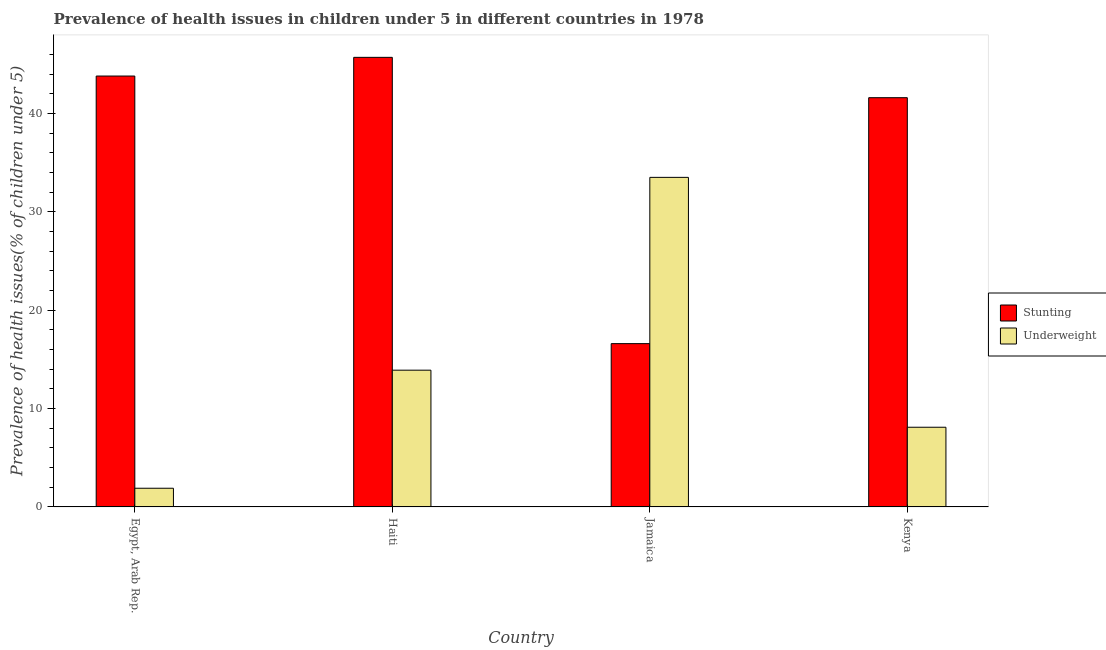Are the number of bars per tick equal to the number of legend labels?
Offer a terse response. Yes. How many bars are there on the 3rd tick from the left?
Give a very brief answer. 2. How many bars are there on the 2nd tick from the right?
Keep it short and to the point. 2. What is the label of the 4th group of bars from the left?
Your response must be concise. Kenya. What is the percentage of underweight children in Haiti?
Make the answer very short. 13.9. Across all countries, what is the maximum percentage of stunted children?
Your answer should be compact. 45.7. Across all countries, what is the minimum percentage of underweight children?
Give a very brief answer. 1.9. In which country was the percentage of underweight children maximum?
Give a very brief answer. Jamaica. In which country was the percentage of underweight children minimum?
Ensure brevity in your answer.  Egypt, Arab Rep. What is the total percentage of stunted children in the graph?
Give a very brief answer. 147.7. What is the difference between the percentage of underweight children in Egypt, Arab Rep. and that in Kenya?
Offer a very short reply. -6.2. What is the difference between the percentage of underweight children in Kenya and the percentage of stunted children in Haiti?
Your response must be concise. -37.6. What is the average percentage of underweight children per country?
Offer a very short reply. 14.35. What is the difference between the percentage of underweight children and percentage of stunted children in Jamaica?
Give a very brief answer. 16.9. In how many countries, is the percentage of underweight children greater than 28 %?
Provide a succinct answer. 1. What is the ratio of the percentage of underweight children in Haiti to that in Kenya?
Your response must be concise. 1.72. What is the difference between the highest and the second highest percentage of underweight children?
Offer a very short reply. 19.6. What is the difference between the highest and the lowest percentage of underweight children?
Your response must be concise. 31.6. Is the sum of the percentage of stunted children in Egypt, Arab Rep. and Kenya greater than the maximum percentage of underweight children across all countries?
Give a very brief answer. Yes. What does the 2nd bar from the left in Haiti represents?
Keep it short and to the point. Underweight. What does the 1st bar from the right in Egypt, Arab Rep. represents?
Offer a terse response. Underweight. How many bars are there?
Offer a very short reply. 8. Are all the bars in the graph horizontal?
Give a very brief answer. No. What is the difference between two consecutive major ticks on the Y-axis?
Ensure brevity in your answer.  10. How many legend labels are there?
Ensure brevity in your answer.  2. What is the title of the graph?
Your response must be concise. Prevalence of health issues in children under 5 in different countries in 1978. Does "Exports of goods" appear as one of the legend labels in the graph?
Offer a very short reply. No. What is the label or title of the X-axis?
Provide a short and direct response. Country. What is the label or title of the Y-axis?
Offer a very short reply. Prevalence of health issues(% of children under 5). What is the Prevalence of health issues(% of children under 5) of Stunting in Egypt, Arab Rep.?
Your response must be concise. 43.8. What is the Prevalence of health issues(% of children under 5) of Underweight in Egypt, Arab Rep.?
Provide a short and direct response. 1.9. What is the Prevalence of health issues(% of children under 5) in Stunting in Haiti?
Provide a short and direct response. 45.7. What is the Prevalence of health issues(% of children under 5) of Underweight in Haiti?
Provide a short and direct response. 13.9. What is the Prevalence of health issues(% of children under 5) in Stunting in Jamaica?
Provide a short and direct response. 16.6. What is the Prevalence of health issues(% of children under 5) in Underweight in Jamaica?
Make the answer very short. 33.5. What is the Prevalence of health issues(% of children under 5) of Stunting in Kenya?
Ensure brevity in your answer.  41.6. What is the Prevalence of health issues(% of children under 5) of Underweight in Kenya?
Your answer should be compact. 8.1. Across all countries, what is the maximum Prevalence of health issues(% of children under 5) of Stunting?
Make the answer very short. 45.7. Across all countries, what is the maximum Prevalence of health issues(% of children under 5) of Underweight?
Give a very brief answer. 33.5. Across all countries, what is the minimum Prevalence of health issues(% of children under 5) in Stunting?
Provide a succinct answer. 16.6. Across all countries, what is the minimum Prevalence of health issues(% of children under 5) of Underweight?
Your answer should be compact. 1.9. What is the total Prevalence of health issues(% of children under 5) in Stunting in the graph?
Ensure brevity in your answer.  147.7. What is the total Prevalence of health issues(% of children under 5) of Underweight in the graph?
Your response must be concise. 57.4. What is the difference between the Prevalence of health issues(% of children under 5) in Stunting in Egypt, Arab Rep. and that in Haiti?
Your answer should be compact. -1.9. What is the difference between the Prevalence of health issues(% of children under 5) in Underweight in Egypt, Arab Rep. and that in Haiti?
Offer a very short reply. -12. What is the difference between the Prevalence of health issues(% of children under 5) in Stunting in Egypt, Arab Rep. and that in Jamaica?
Give a very brief answer. 27.2. What is the difference between the Prevalence of health issues(% of children under 5) in Underweight in Egypt, Arab Rep. and that in Jamaica?
Offer a very short reply. -31.6. What is the difference between the Prevalence of health issues(% of children under 5) of Stunting in Egypt, Arab Rep. and that in Kenya?
Provide a succinct answer. 2.2. What is the difference between the Prevalence of health issues(% of children under 5) of Stunting in Haiti and that in Jamaica?
Ensure brevity in your answer.  29.1. What is the difference between the Prevalence of health issues(% of children under 5) in Underweight in Haiti and that in Jamaica?
Keep it short and to the point. -19.6. What is the difference between the Prevalence of health issues(% of children under 5) in Stunting in Haiti and that in Kenya?
Offer a terse response. 4.1. What is the difference between the Prevalence of health issues(% of children under 5) in Underweight in Haiti and that in Kenya?
Provide a short and direct response. 5.8. What is the difference between the Prevalence of health issues(% of children under 5) of Underweight in Jamaica and that in Kenya?
Ensure brevity in your answer.  25.4. What is the difference between the Prevalence of health issues(% of children under 5) in Stunting in Egypt, Arab Rep. and the Prevalence of health issues(% of children under 5) in Underweight in Haiti?
Keep it short and to the point. 29.9. What is the difference between the Prevalence of health issues(% of children under 5) in Stunting in Egypt, Arab Rep. and the Prevalence of health issues(% of children under 5) in Underweight in Jamaica?
Your answer should be compact. 10.3. What is the difference between the Prevalence of health issues(% of children under 5) in Stunting in Egypt, Arab Rep. and the Prevalence of health issues(% of children under 5) in Underweight in Kenya?
Ensure brevity in your answer.  35.7. What is the difference between the Prevalence of health issues(% of children under 5) of Stunting in Haiti and the Prevalence of health issues(% of children under 5) of Underweight in Jamaica?
Keep it short and to the point. 12.2. What is the difference between the Prevalence of health issues(% of children under 5) in Stunting in Haiti and the Prevalence of health issues(% of children under 5) in Underweight in Kenya?
Give a very brief answer. 37.6. What is the difference between the Prevalence of health issues(% of children under 5) in Stunting in Jamaica and the Prevalence of health issues(% of children under 5) in Underweight in Kenya?
Offer a terse response. 8.5. What is the average Prevalence of health issues(% of children under 5) of Stunting per country?
Offer a very short reply. 36.92. What is the average Prevalence of health issues(% of children under 5) of Underweight per country?
Provide a short and direct response. 14.35. What is the difference between the Prevalence of health issues(% of children under 5) of Stunting and Prevalence of health issues(% of children under 5) of Underweight in Egypt, Arab Rep.?
Your response must be concise. 41.9. What is the difference between the Prevalence of health issues(% of children under 5) in Stunting and Prevalence of health issues(% of children under 5) in Underweight in Haiti?
Make the answer very short. 31.8. What is the difference between the Prevalence of health issues(% of children under 5) of Stunting and Prevalence of health issues(% of children under 5) of Underweight in Jamaica?
Your response must be concise. -16.9. What is the difference between the Prevalence of health issues(% of children under 5) in Stunting and Prevalence of health issues(% of children under 5) in Underweight in Kenya?
Your answer should be compact. 33.5. What is the ratio of the Prevalence of health issues(% of children under 5) of Stunting in Egypt, Arab Rep. to that in Haiti?
Give a very brief answer. 0.96. What is the ratio of the Prevalence of health issues(% of children under 5) in Underweight in Egypt, Arab Rep. to that in Haiti?
Your answer should be compact. 0.14. What is the ratio of the Prevalence of health issues(% of children under 5) of Stunting in Egypt, Arab Rep. to that in Jamaica?
Offer a terse response. 2.64. What is the ratio of the Prevalence of health issues(% of children under 5) of Underweight in Egypt, Arab Rep. to that in Jamaica?
Offer a very short reply. 0.06. What is the ratio of the Prevalence of health issues(% of children under 5) in Stunting in Egypt, Arab Rep. to that in Kenya?
Ensure brevity in your answer.  1.05. What is the ratio of the Prevalence of health issues(% of children under 5) in Underweight in Egypt, Arab Rep. to that in Kenya?
Provide a short and direct response. 0.23. What is the ratio of the Prevalence of health issues(% of children under 5) in Stunting in Haiti to that in Jamaica?
Your answer should be very brief. 2.75. What is the ratio of the Prevalence of health issues(% of children under 5) in Underweight in Haiti to that in Jamaica?
Offer a terse response. 0.41. What is the ratio of the Prevalence of health issues(% of children under 5) of Stunting in Haiti to that in Kenya?
Your answer should be compact. 1.1. What is the ratio of the Prevalence of health issues(% of children under 5) in Underweight in Haiti to that in Kenya?
Provide a short and direct response. 1.72. What is the ratio of the Prevalence of health issues(% of children under 5) in Stunting in Jamaica to that in Kenya?
Provide a succinct answer. 0.4. What is the ratio of the Prevalence of health issues(% of children under 5) of Underweight in Jamaica to that in Kenya?
Provide a short and direct response. 4.14. What is the difference between the highest and the second highest Prevalence of health issues(% of children under 5) of Underweight?
Give a very brief answer. 19.6. What is the difference between the highest and the lowest Prevalence of health issues(% of children under 5) in Stunting?
Your answer should be compact. 29.1. What is the difference between the highest and the lowest Prevalence of health issues(% of children under 5) in Underweight?
Your response must be concise. 31.6. 